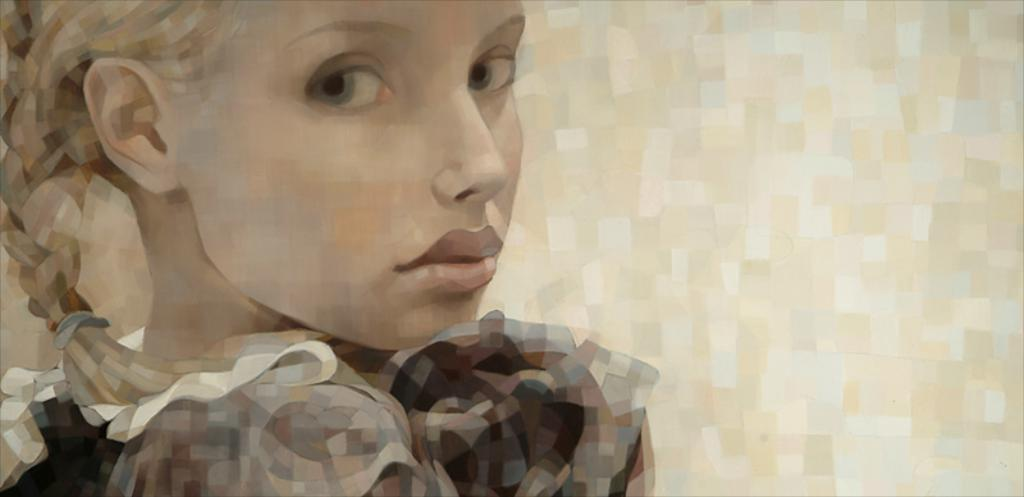What is the main subject of the image? There is a painting in the image. What does the painting depict? The painting depicts a woman. How many chairs are visible in the painting? There are no chairs visible in the painting, as it only depicts a woman. Can you touch the woman in the painting? You cannot touch the woman in the painting, as it is a two-dimensional representation. 